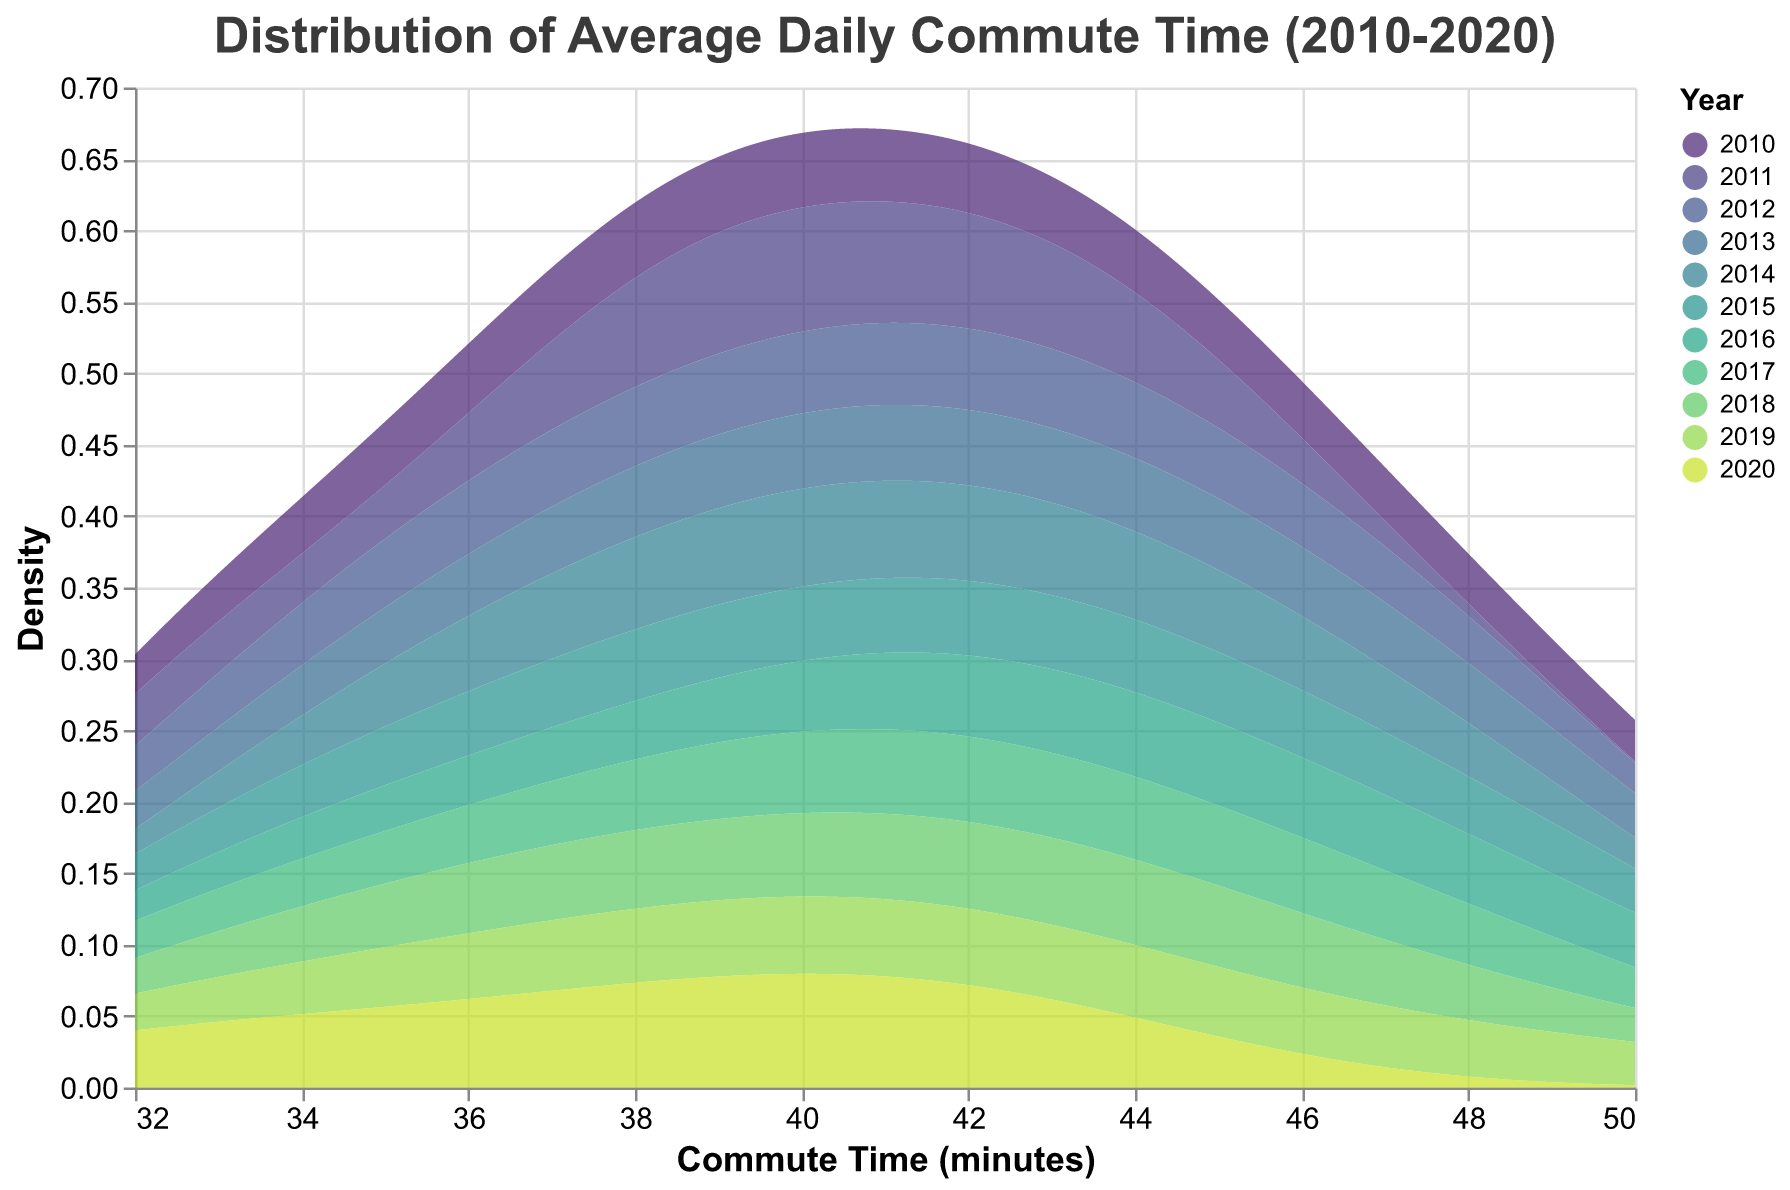What does the title of the density plot read? The title of the figure is clearly written at the top.
Answer: Distribution of Average Daily Commute Time (2010-2020) What are the axes titles on the density plot? The x-axis title is positioned horizontally at the bottom, and the y-axis title is vertically aligned on the left side. The x-axis is labeled "Commute Time (minutes)" and the y-axis is labeled "Density."
Answer: Commute Time (minutes) and Density How does the commute time distribution for 2010 compare to that of 2020? Observe the overlapping density curves for the years 2010 and 2020. Focus on the spread and peaks of each density curve. The density for 2010 seems to be more spread out, indicating a wider range of commute times, whereas the density for 2020 is more concentrated, showing a narrower range of commute times.
Answer: 2010 is more spread out; 2020 is more concentrated Which year has the highest peak density for commute time? Look for the highest point on the y-axis across all the years. The year with the peak that reaches the highest value on the y-axis will be the answer.
Answer: It needs to be determined by looking at the plot What is the range of commute times covered in this plot? Examine the x-axis to see the minimum and maximum values displayed. Note the lowest and highest commute times shown. The commute times range from approximately 30 minutes to 50 minutes.
Answer: 30 to 50 minutes Which year shows the widest range in commute time? Look at the spread of the density curves for each year on the x-axis. The year with the curve covering the broadest range of commute times indicates the widest spread.
Answer: It needs to be determined by looking at the plot Between 2015 and 2018, which year has a higher peak density? Compare the highest points of the density curves for 2015 and 2018. The year with the higher peak on the y-axis has the higher peak density.
Answer: It needs to be determined by looking at the plot Identify a year with a generally decreasing spread in commute times compared to its previous year? Compare the density curves of each adjacent year. Find a pair where the density curve of the later year is less spread out than the previous year.
Answer: It needs to be determined by looking at the plot What can you infer about the change in commute times from 2010 to 2020? Observe the shift in the density curves from 2010 to 2020. Note changes in the means, spreads, and peaks of the distributions. Generally, the 2020 curve appears more narrow and peaks at shorter commute times, indicating a reduction in commute time spreads and possibly shorter average commute times.
Answer: Narrower spread, shorter commute times How do the densities of 2016 and 2017 compare in terms of spread and peak? Examine the density curves of 2016 and 2017. Assess the spread (width) and the height of the peaks of both years. The comparison should highlight whether one year has a more spread-out distribution or a higher peak than the other.
Answer: It needs to be determined by looking at the plot 